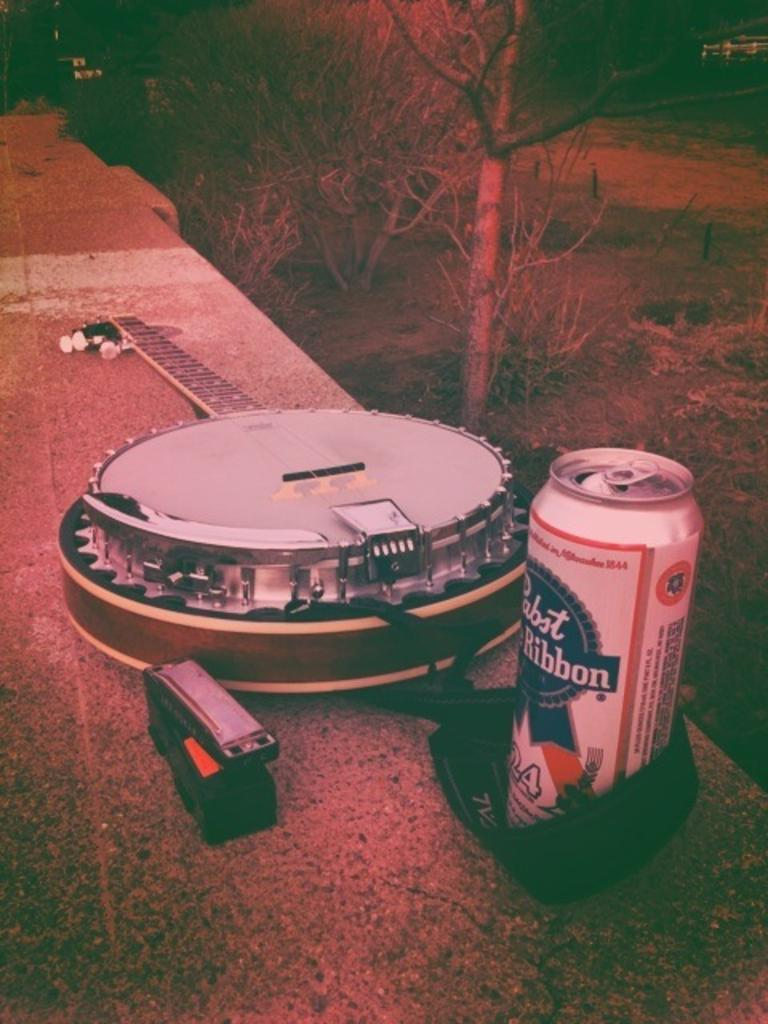Provide a one-sentence caption for the provided image. Beer and guitar sitting beside each other on a ledge. 